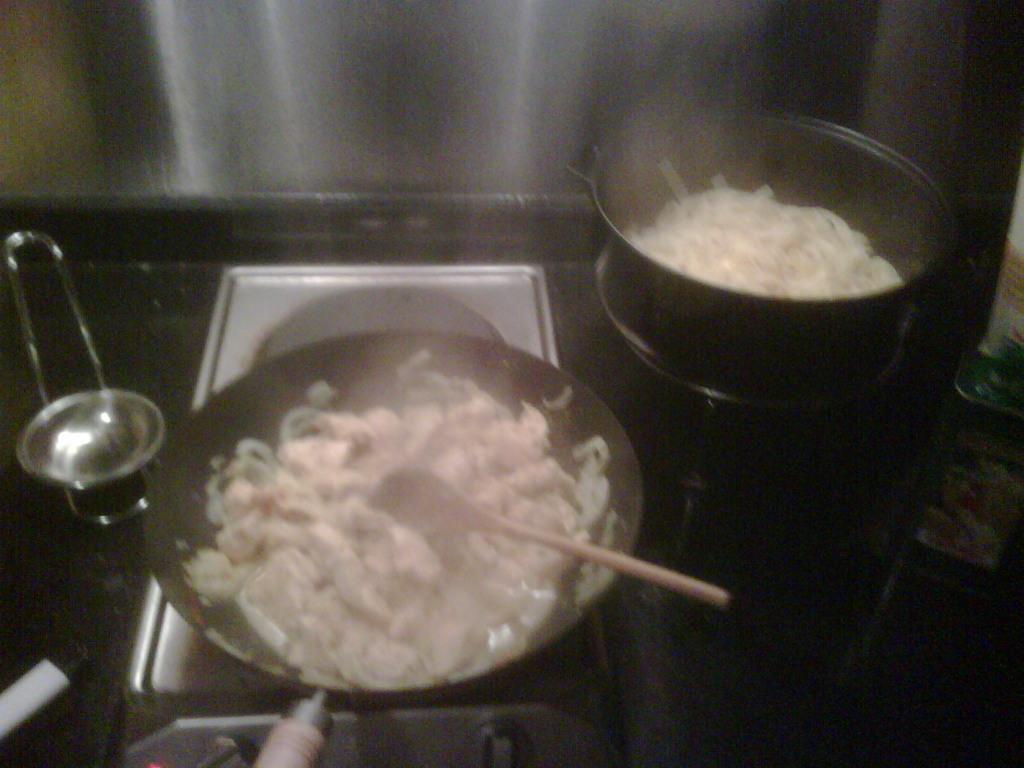How would you summarize this image in a sentence or two? There are utensils on the stoves which contains food items. There is a wooden spatula in a vessel. 